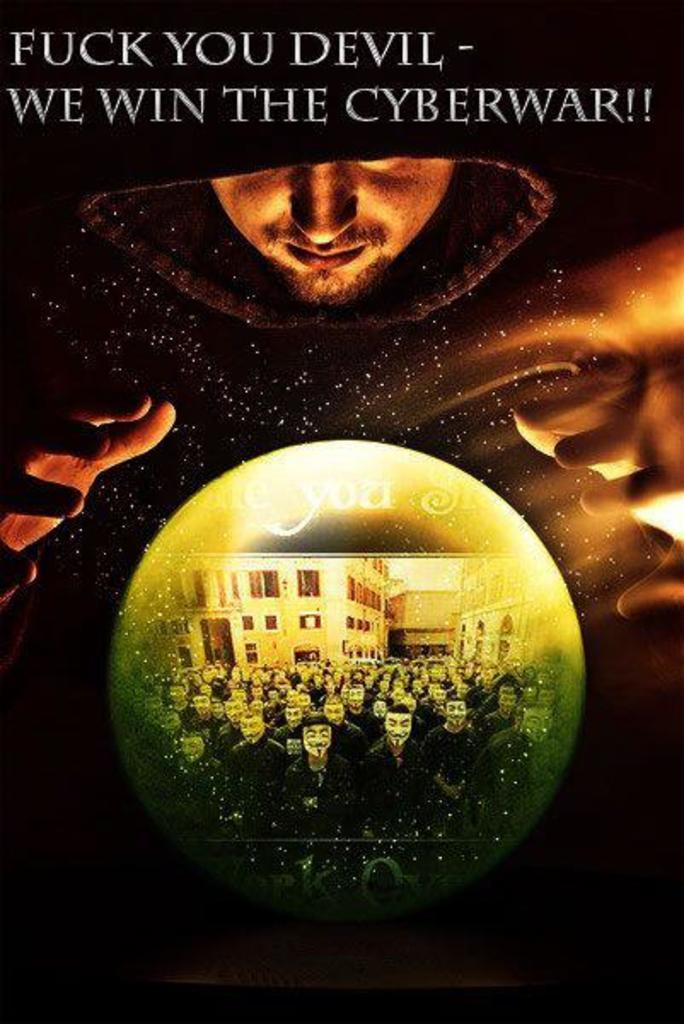<image>
Render a clear and concise summary of the photo. the word devil is on a black poster with a man on it 